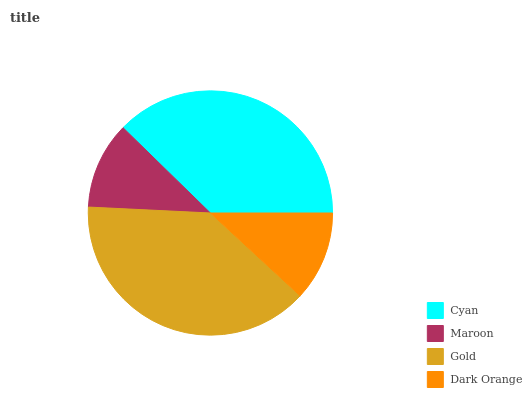Is Maroon the minimum?
Answer yes or no. Yes. Is Gold the maximum?
Answer yes or no. Yes. Is Gold the minimum?
Answer yes or no. No. Is Maroon the maximum?
Answer yes or no. No. Is Gold greater than Maroon?
Answer yes or no. Yes. Is Maroon less than Gold?
Answer yes or no. Yes. Is Maroon greater than Gold?
Answer yes or no. No. Is Gold less than Maroon?
Answer yes or no. No. Is Cyan the high median?
Answer yes or no. Yes. Is Dark Orange the low median?
Answer yes or no. Yes. Is Maroon the high median?
Answer yes or no. No. Is Gold the low median?
Answer yes or no. No. 